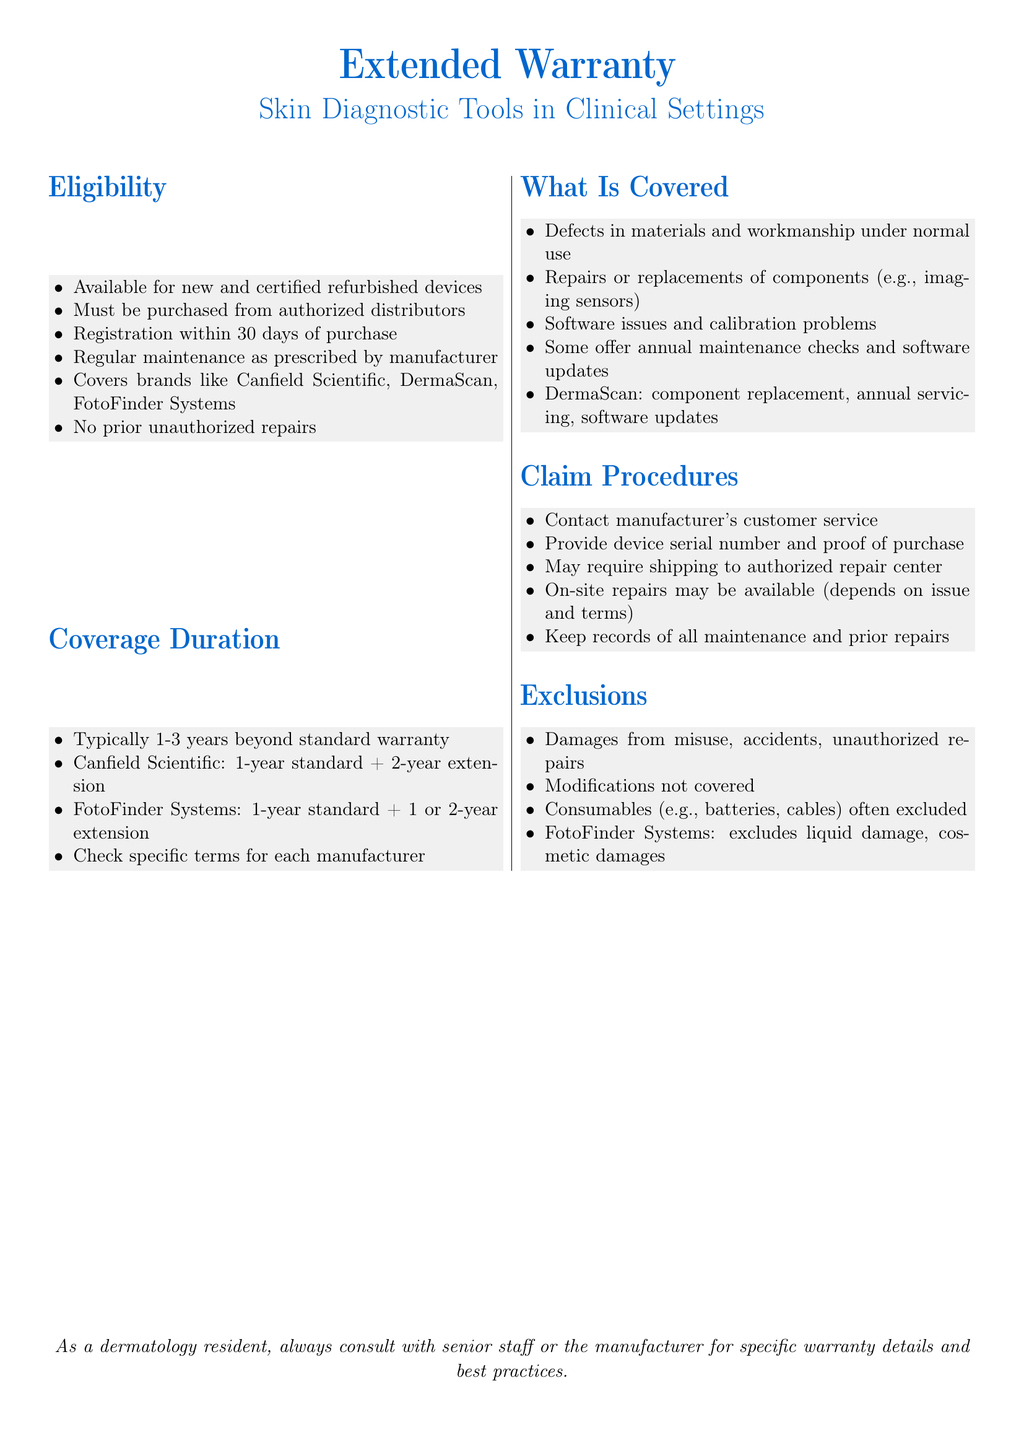what is the maximum duration for an extended warranty? The maximum duration for an extended warranty can be 1-3 years beyond the standard warranty.
Answer: 3 years what devices are eligible for the extended warranty? The extended warranty is available for new and certified refurbished devices.
Answer: new and certified refurbished devices how soon must registration occur after purchase? Registration must occur within 30 days of purchase.
Answer: 30 days who must the warranty be purchased from? The warranty must be purchased from authorized distributors.
Answer: authorized distributors which brand offers a 1-year standard plus 2-year extension? Canfield Scientific offers a 1-year standard plus a 2-year extension.
Answer: Canfield Scientific what is excluded from the warranty coverage? Damages from misuse, accidents, and unauthorized repairs are excluded from the warranty coverage.
Answer: damages from misuse what is required to initiate a claim? To initiate a claim, the manufacturer’s customer service must be contacted and the device's serial number and proof of purchase provided.
Answer: contact manufacturer’s customer service how are defects under normal use classified in the warranty? Defects in materials and workmanship under normal use are covered by the warranty.
Answer: defects in materials and workmanship what type of repairs may require shipping to an authorized repair center? Repairs may require shipping to an authorized repair center for various issues.
Answer: shipping to authorized repair center what type of maintenance is mentioned for DermaScan? Annual servicing and software updates are mentioned for DermaScan.
Answer: annual servicing and software updates 